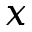Convert formula to latex. <formula><loc_0><loc_0><loc_500><loc_500>x</formula> 